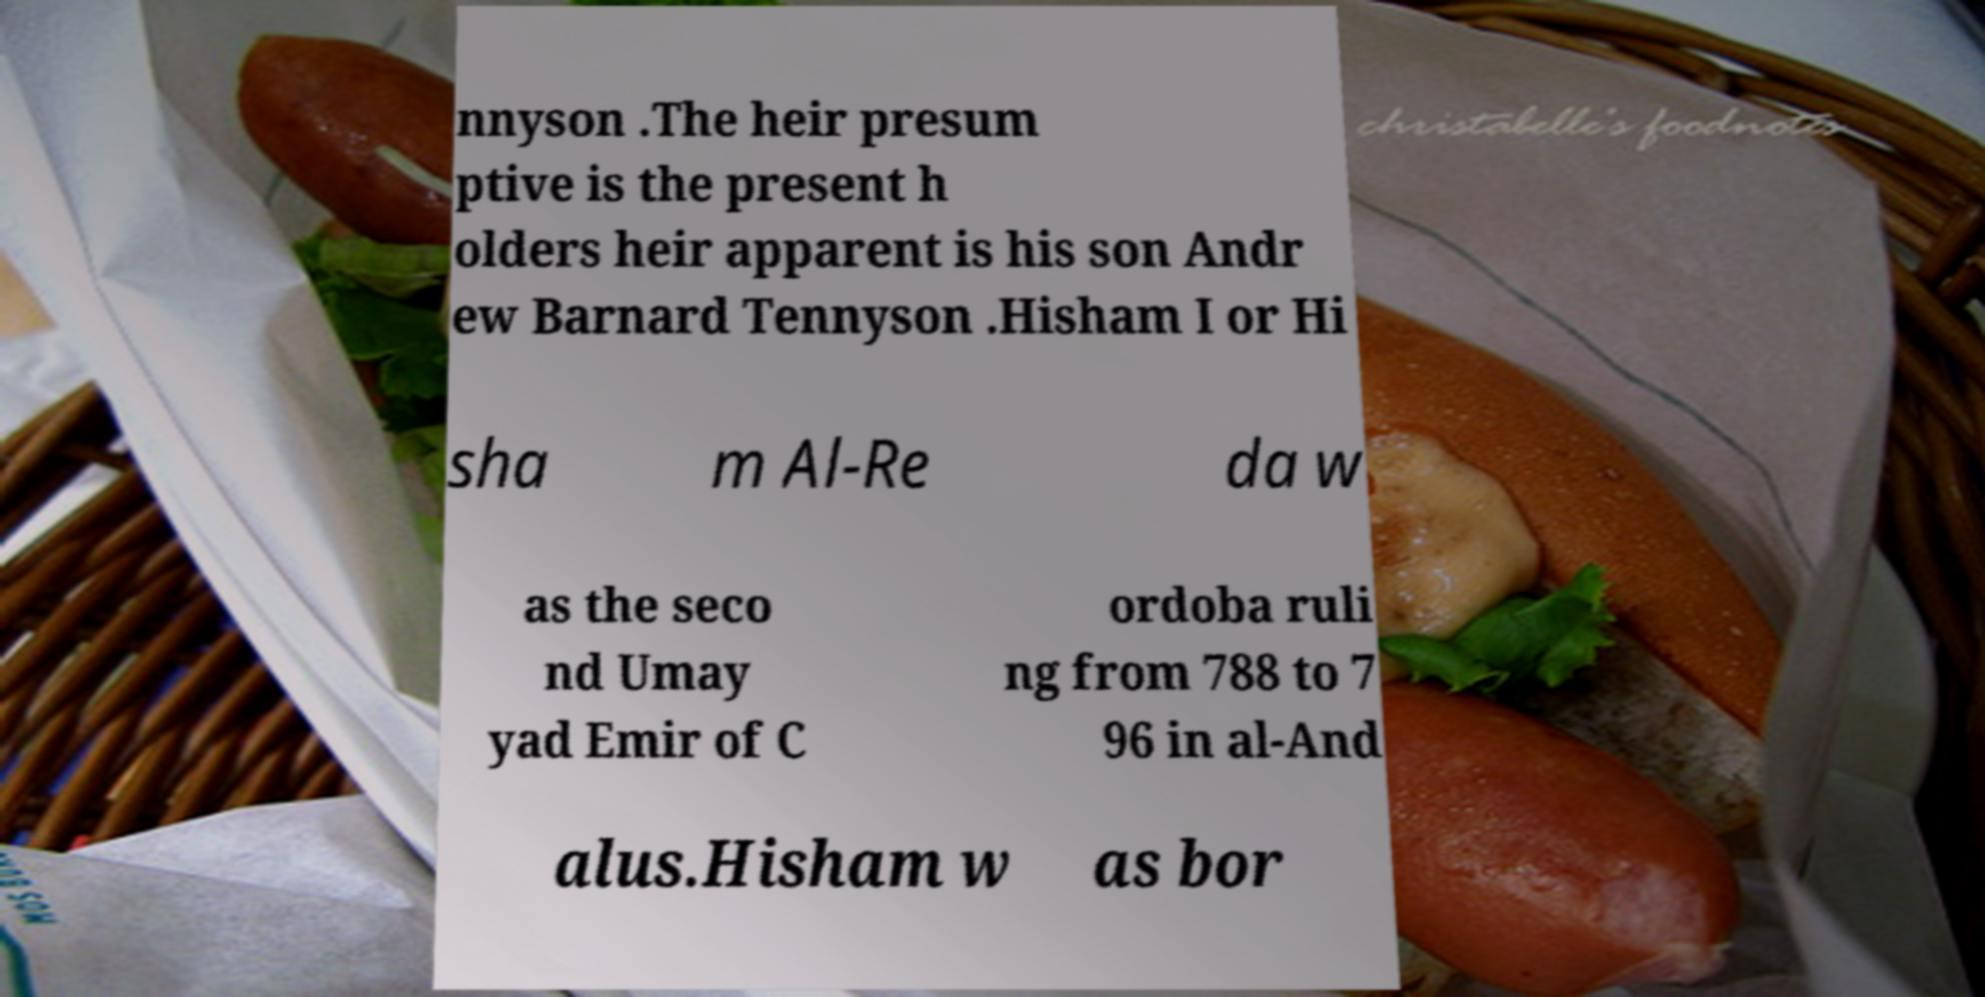Please read and relay the text visible in this image. What does it say? nnyson .The heir presum ptive is the present h olders heir apparent is his son Andr ew Barnard Tennyson .Hisham I or Hi sha m Al-Re da w as the seco nd Umay yad Emir of C ordoba ruli ng from 788 to 7 96 in al-And alus.Hisham w as bor 